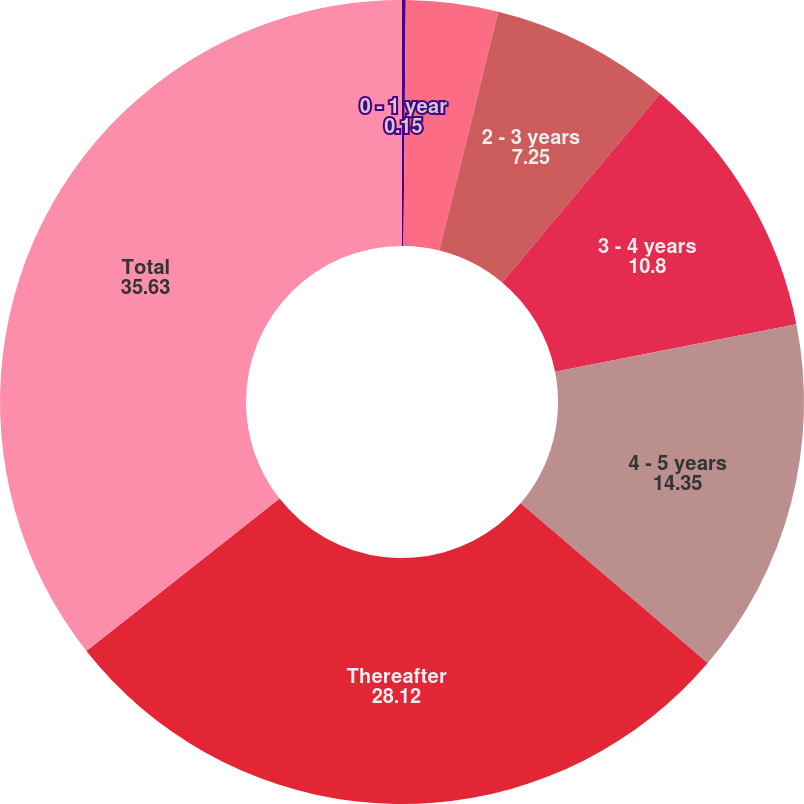Convert chart. <chart><loc_0><loc_0><loc_500><loc_500><pie_chart><fcel>0 - 1 year<fcel>1 - 2 years<fcel>2 - 3 years<fcel>3 - 4 years<fcel>4 - 5 years<fcel>Thereafter<fcel>Total<nl><fcel>0.15%<fcel>3.7%<fcel>7.25%<fcel>10.8%<fcel>14.35%<fcel>28.12%<fcel>35.63%<nl></chart> 